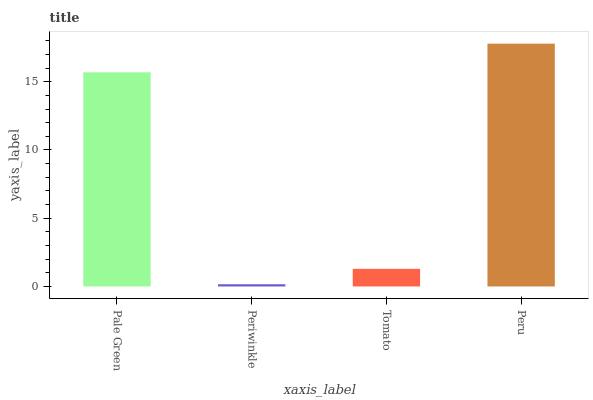Is Tomato the minimum?
Answer yes or no. No. Is Tomato the maximum?
Answer yes or no. No. Is Tomato greater than Periwinkle?
Answer yes or no. Yes. Is Periwinkle less than Tomato?
Answer yes or no. Yes. Is Periwinkle greater than Tomato?
Answer yes or no. No. Is Tomato less than Periwinkle?
Answer yes or no. No. Is Pale Green the high median?
Answer yes or no. Yes. Is Tomato the low median?
Answer yes or no. Yes. Is Peru the high median?
Answer yes or no. No. Is Periwinkle the low median?
Answer yes or no. No. 